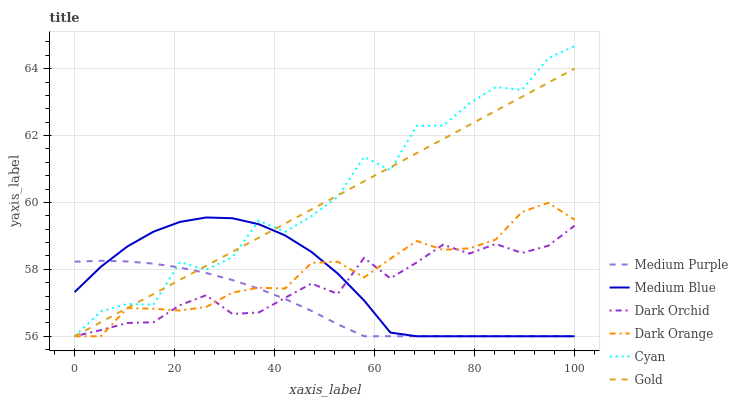Does Medium Purple have the minimum area under the curve?
Answer yes or no. Yes. Does Cyan have the maximum area under the curve?
Answer yes or no. Yes. Does Gold have the minimum area under the curve?
Answer yes or no. No. Does Gold have the maximum area under the curve?
Answer yes or no. No. Is Gold the smoothest?
Answer yes or no. Yes. Is Cyan the roughest?
Answer yes or no. Yes. Is Medium Blue the smoothest?
Answer yes or no. No. Is Medium Blue the roughest?
Answer yes or no. No. Does Cyan have the highest value?
Answer yes or no. Yes. Does Gold have the highest value?
Answer yes or no. No. Does Cyan intersect Medium Blue?
Answer yes or no. Yes. Is Cyan less than Medium Blue?
Answer yes or no. No. Is Cyan greater than Medium Blue?
Answer yes or no. No. 